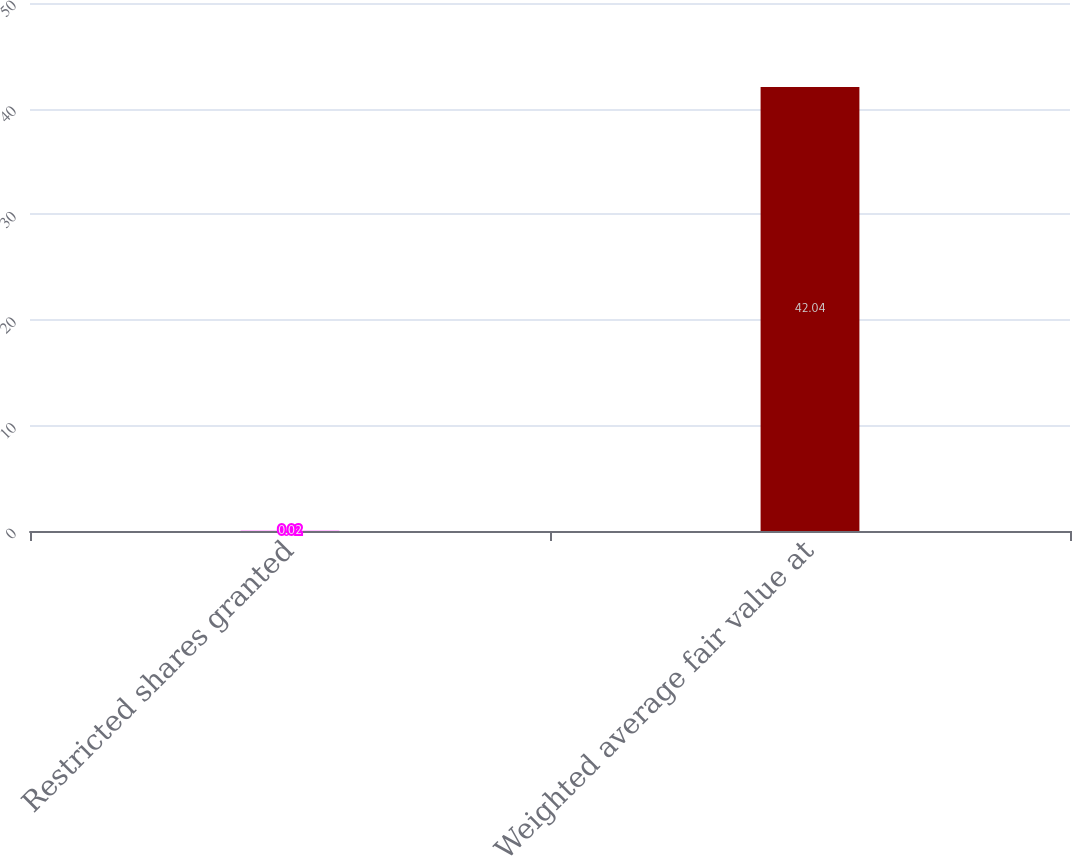<chart> <loc_0><loc_0><loc_500><loc_500><bar_chart><fcel>Restricted shares granted<fcel>Weighted average fair value at<nl><fcel>0.02<fcel>42.04<nl></chart> 